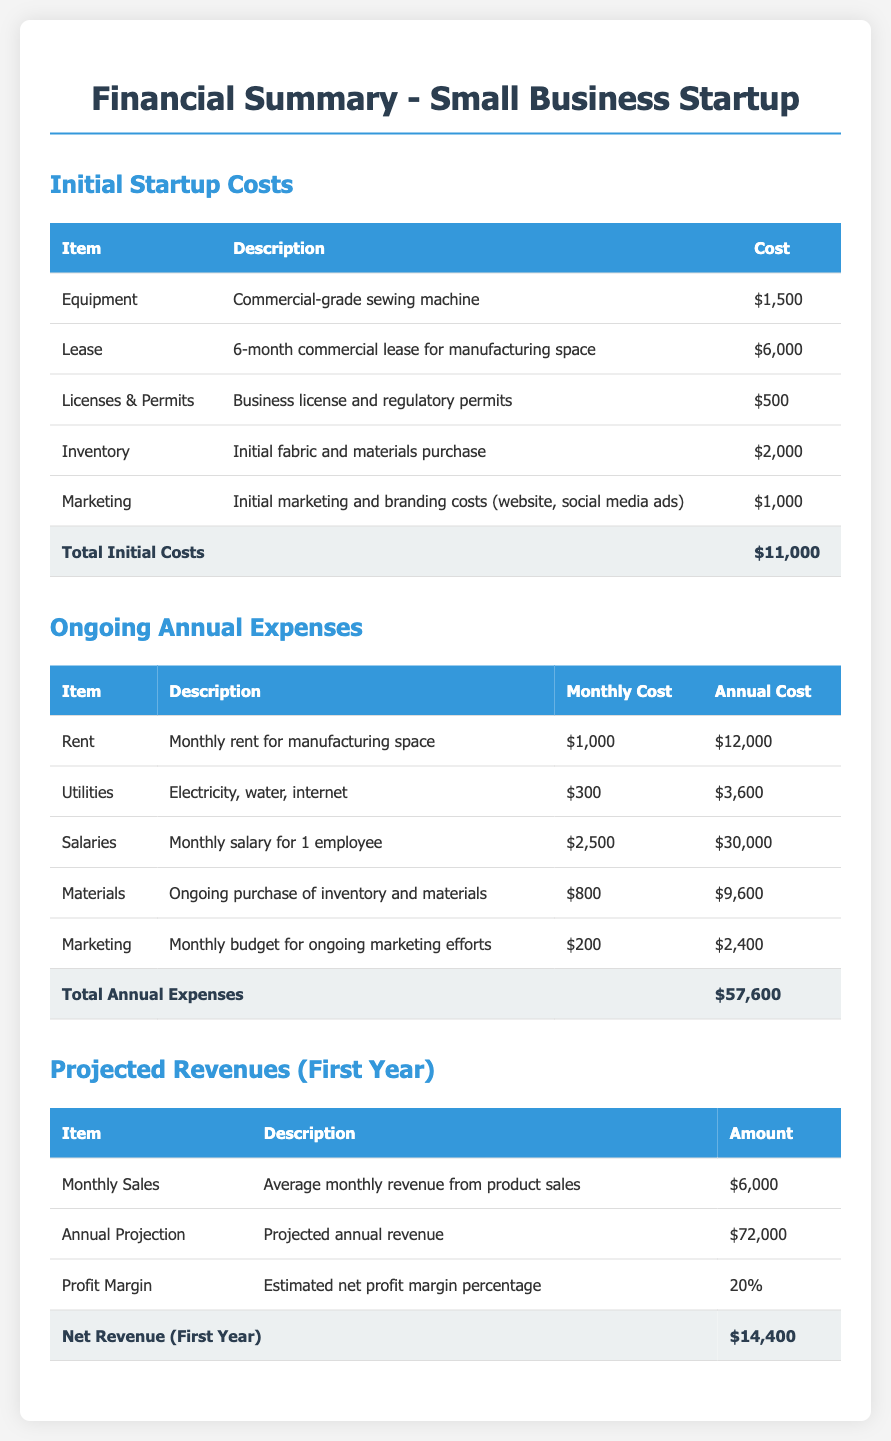What are the total initial costs? The total initial costs section clearly states the total as $11,000.
Answer: $11,000 How much does the business plan to earn monthly? The document specifies the average monthly revenue from product sales as $6,000.
Answer: $6,000 What is the annual cost for salaries? The ongoing annual expenses section lists the annual cost for salaries as $30,000.
Answer: $30,000 What is the cost for inventory? In the initial startup costs, the cost for initial fabric and materials purchase is $2,000.
Answer: $2,000 What is the total annual expense? The total annual expenses in the document are mentioned as $57,600.
Answer: $57,600 What is the projected annual revenue? According to the projected revenues section, the projected annual revenue is $72,000.
Answer: $72,000 What is the estimated net profit margin percentage? The document states that the estimated net profit margin percentage is 20%.
Answer: 20% What is the total cost for marketing? The ongoing annual marketing cost is detailed as $2,400.
Answer: $2,400 What are the initial costs for licenses and permits? The licenses and permits cost is listed as $500 in the initial startup costs.
Answer: $500 